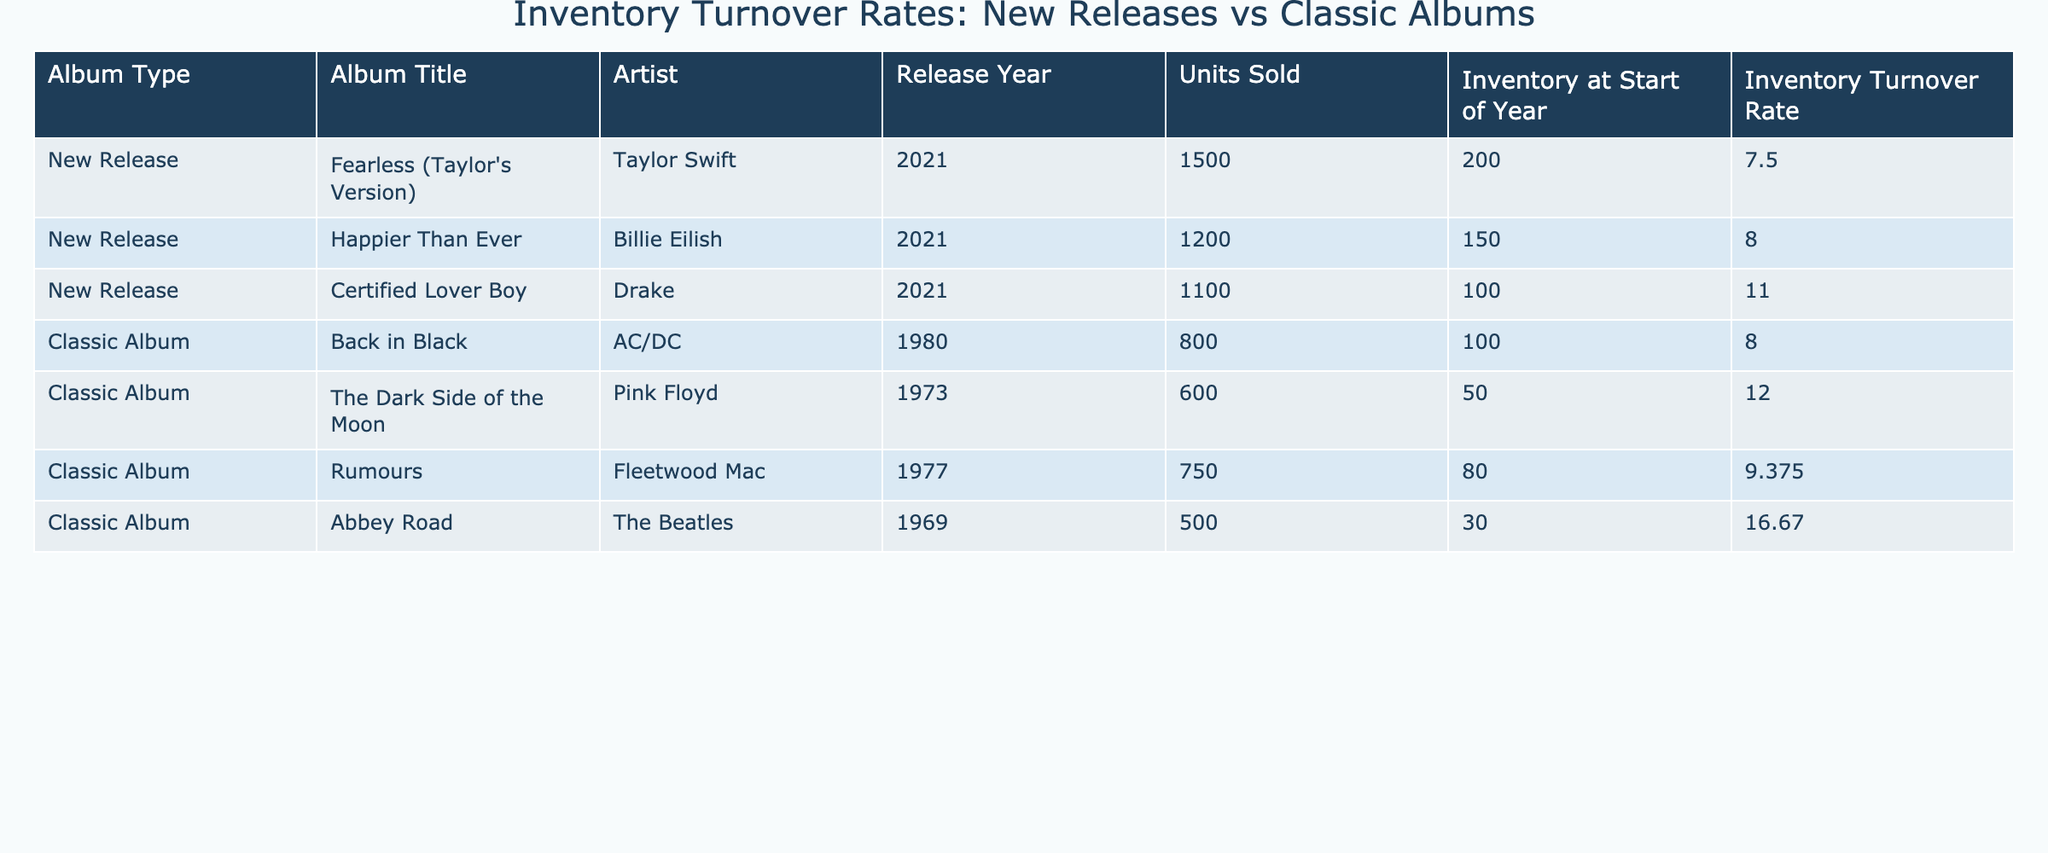What is the inventory turnover rate for "Fearless (Taylor's Version)"? From the table, the inventory turnover rate for "Fearless (Taylor's Version)" is directly listed in the corresponding row. It is noted as 7.5.
Answer: 7.5 Which classic album has the highest inventory turnover rate? Upon reviewing the table, we see the inventory turnover rates for classic albums: Back in Black is 8.0, The Dark Side of the Moon is 12.0, Rumours is 9.375, and Abbey Road is 16.67. The highest value among these is 16.67 for Abbey Road.
Answer: Abbey Road What is the total number of units sold for all new releases? To find the total units sold for new releases, we add the units sold for each new release: 1500 (Fearless) + 1200 (Happier Than Ever) + 1100 (Certified Lover Boy) = 3800.
Answer: 3800 Is the inventory turnover rate for "Certified Lover Boy" greater than that for "Back in Black"? The inventory turnover rate for "Certified Lover Boy" is 11.0 and for "Back in Black," it is 8.0. Since 11.0 is greater than 8.0, the statement is true.
Answer: Yes What is the average inventory turnover rate for classic albums? First, we must sum the inventory turnover rates of all classic albums: 8.0 + 12.0 + 9.375 + 16.67 = 46.045. Then, dividing this by the number of classic albums (4), we get 46.045 / 4 = 11.51125, which rounds to approximately 11.51.
Answer: 11.51 How many units sold does the album "The Dark Side of the Moon" have compared to the average units sold of all albums listed? "The Dark Side of the Moon" has 600 units sold. The average units sold across all albums is calculated by summing all units sold (1500 + 1200 + 1100 + 800 + 600 + 750 + 500) = 4550, then dividing by the number of albums (7) gives: 4550 / 7 = 650. Since 600 is less than 650, the comparison shows that it has fewer units sold than the average.
Answer: Fewer Is there more inventory at the start of the year for new releases than for classic albums? Summing the inventory at the start of the year for new releases gives: 200 + 150 + 100 = 450. For classic albums: 100 + 50 + 80 + 30 = 260. Since 450 is greater than 260, the statement is true.
Answer: Yes Which artist had the highest units sold in this table? Reviewing the units sold by each artist: Taylor Swift with 1500, Billie Eilish with 1200, Drake with 1100, AC/DC with 800, Pink Floyd with 600, Fleetwood Mac with 750, and The Beatles with 500. The highest value is 1500 by Taylor Swift.
Answer: Taylor Swift 